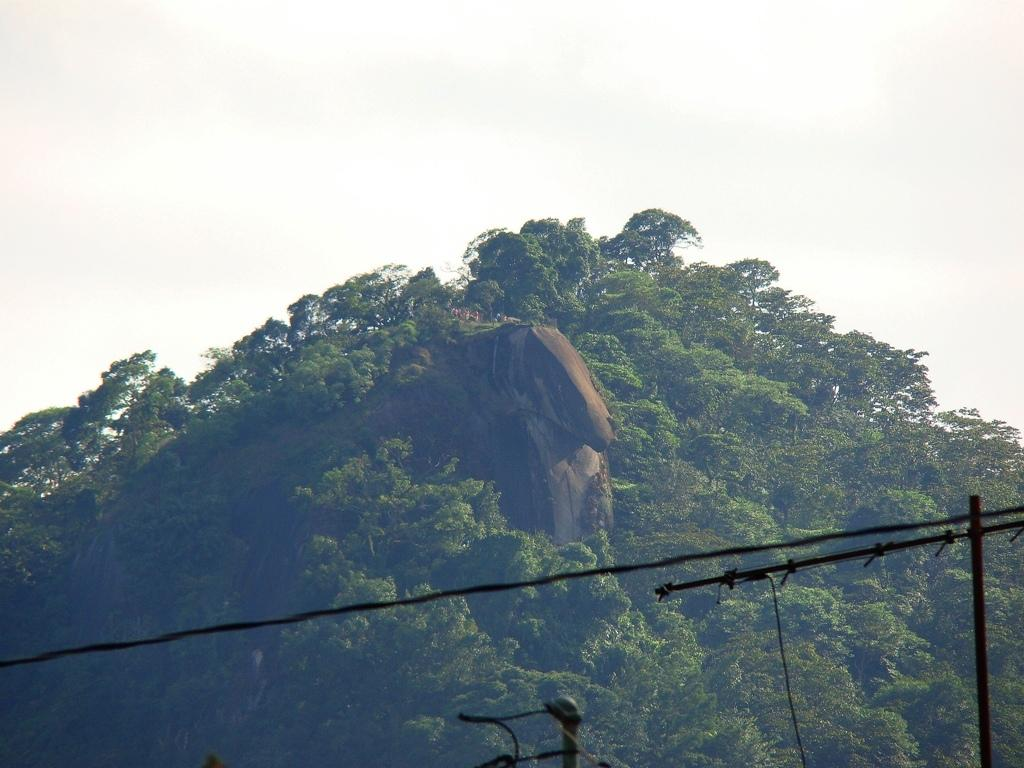What type of landscape feature is present in the image? There is a hill in the image. What can be found on the hill? The hill has trees and plants. What is visible in the background of the image? There is a sky visible in the background of the image. What type of drum can be seen being played on the hill in the image? There is no drum present in the image; it features a hill with trees and plants. What time of day is it in the image, as indicated by the watch on the hill? There is no watch present in the image; it only shows a hill with trees and plants. 